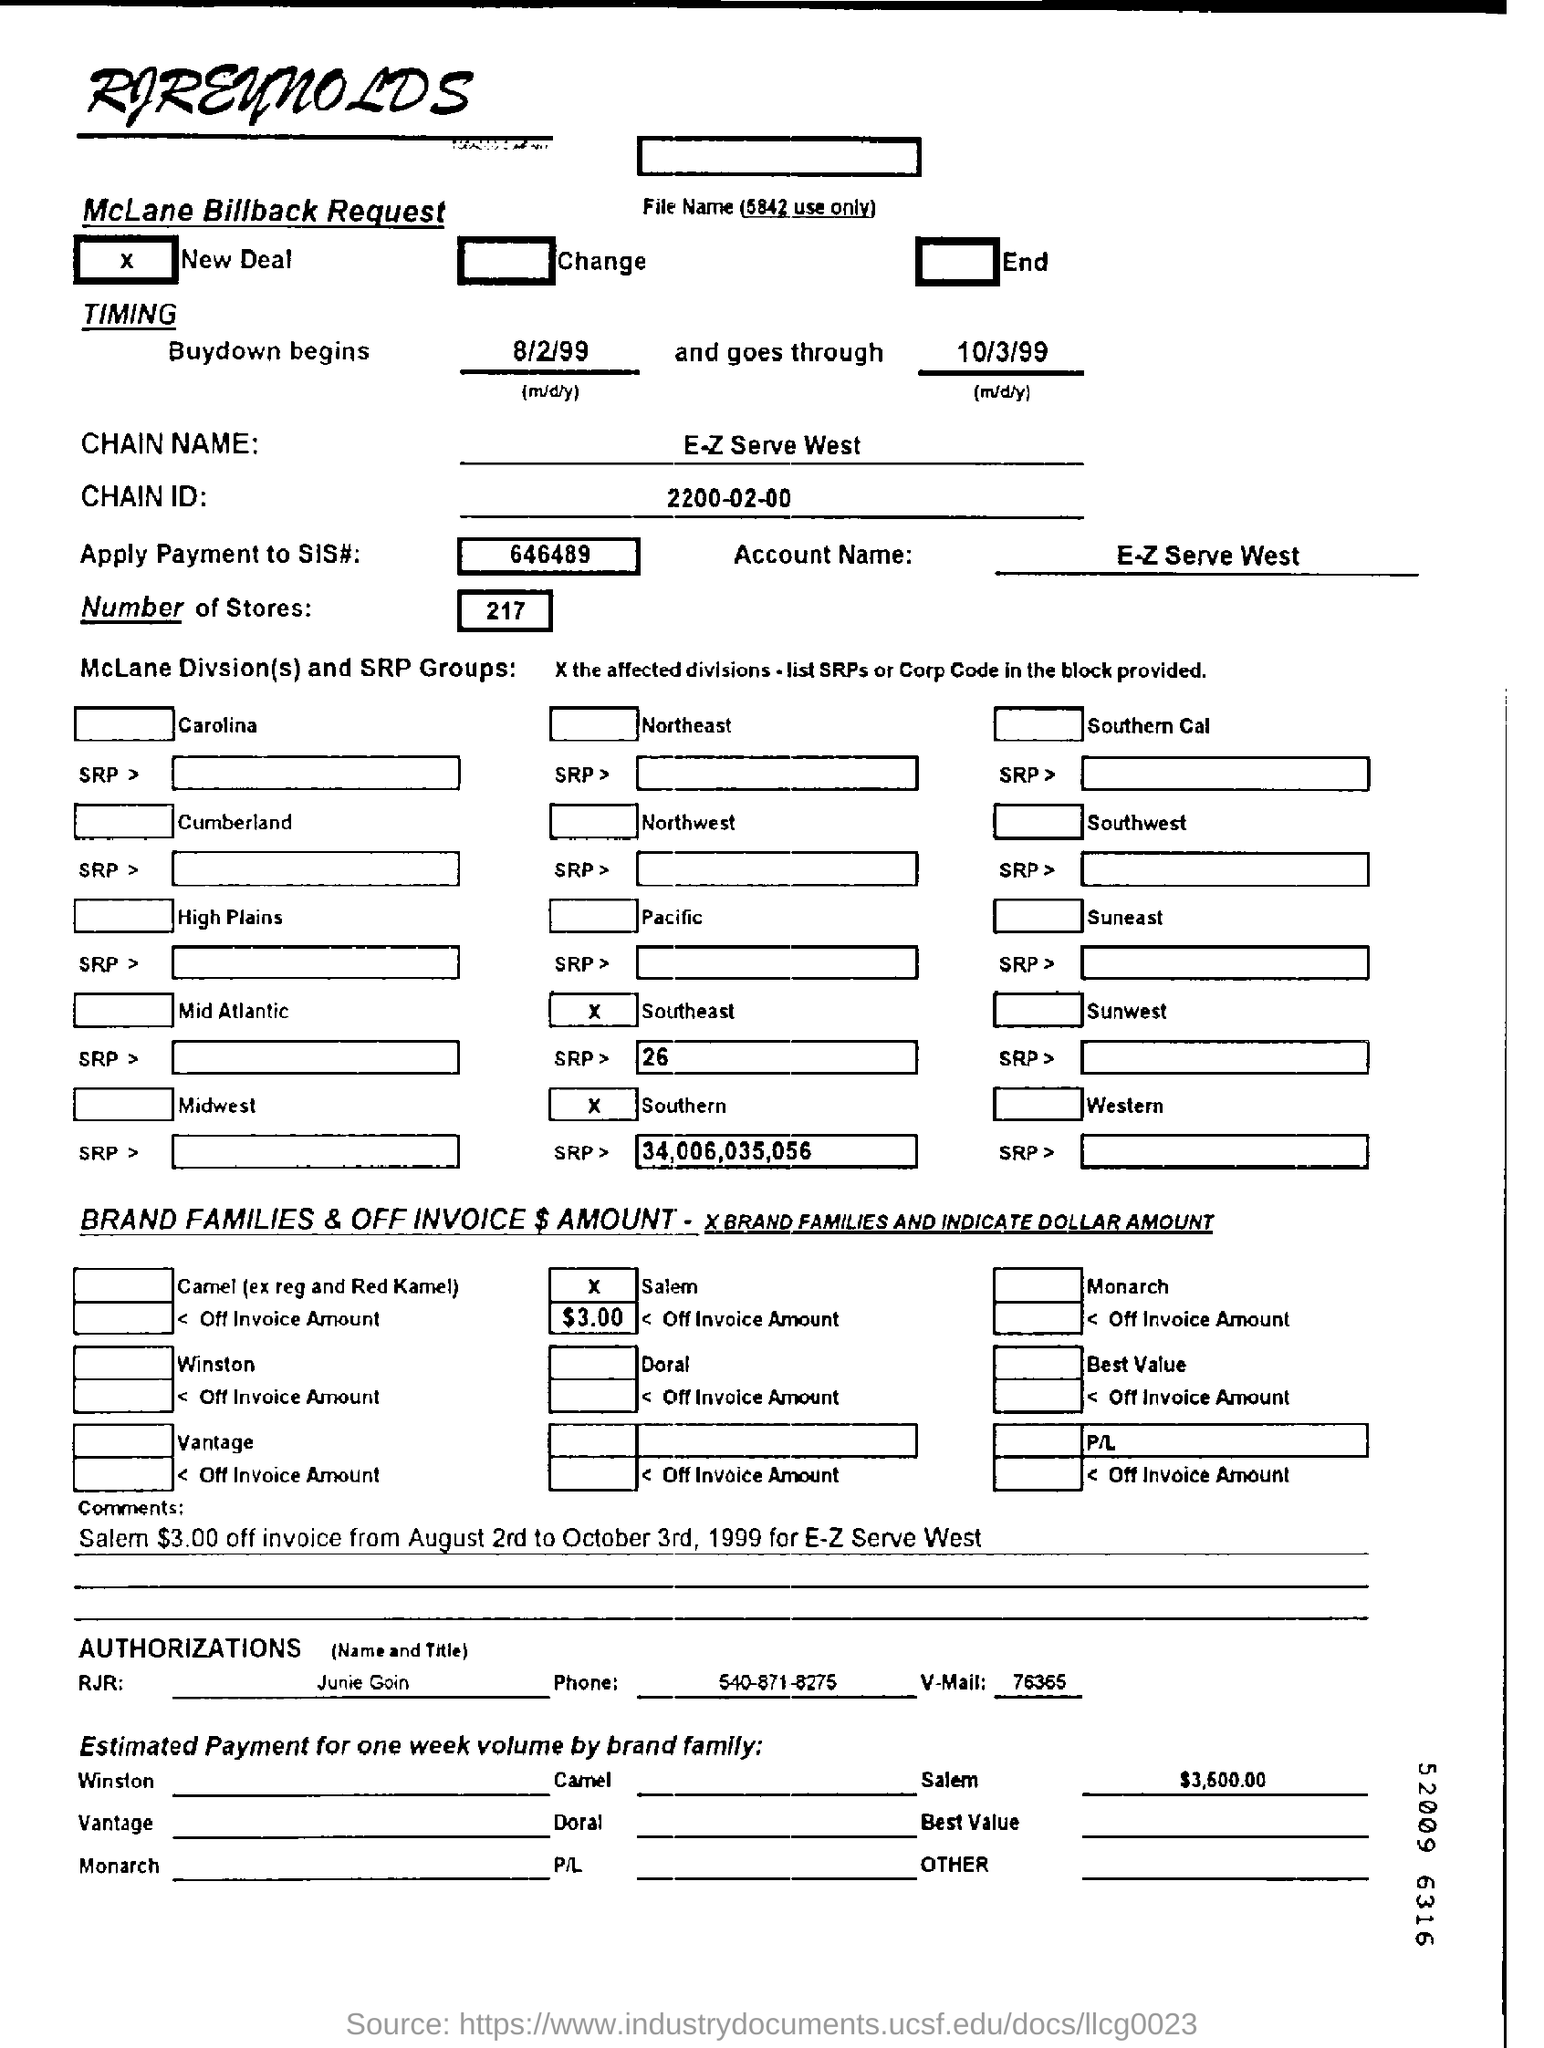Highlight a few significant elements in this photo. The name of the chain is E-Z Serve West. The question asks for the total number of stores. The answer is 217 stores. On August 2nd, 1999, when does the buydown begin? What is the application to make a payment to SIS number 646489? The company whose name appears at the top of the page is RJReynolds. 